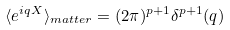<formula> <loc_0><loc_0><loc_500><loc_500>\langle e ^ { i q X } \rangle _ { m a t t e r } = ( 2 \pi ) ^ { p + 1 } \delta ^ { p + 1 } ( q )</formula> 